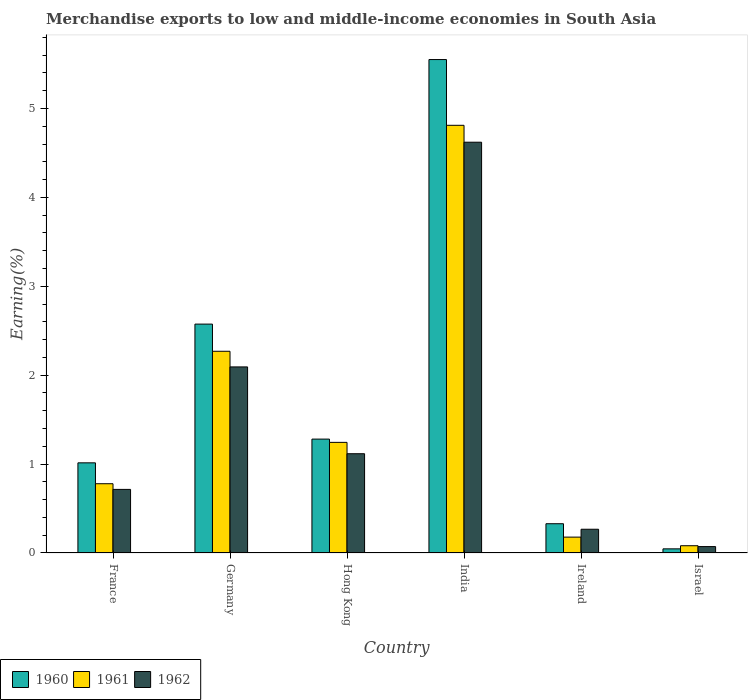How many bars are there on the 2nd tick from the left?
Make the answer very short. 3. How many bars are there on the 1st tick from the right?
Ensure brevity in your answer.  3. What is the label of the 5th group of bars from the left?
Your answer should be very brief. Ireland. What is the percentage of amount earned from merchandise exports in 1960 in Germany?
Your response must be concise. 2.57. Across all countries, what is the maximum percentage of amount earned from merchandise exports in 1960?
Your response must be concise. 5.55. Across all countries, what is the minimum percentage of amount earned from merchandise exports in 1960?
Offer a terse response. 0.05. In which country was the percentage of amount earned from merchandise exports in 1961 minimum?
Provide a succinct answer. Israel. What is the total percentage of amount earned from merchandise exports in 1962 in the graph?
Your answer should be compact. 8.88. What is the difference between the percentage of amount earned from merchandise exports in 1962 in France and that in Hong Kong?
Make the answer very short. -0.4. What is the difference between the percentage of amount earned from merchandise exports in 1962 in Germany and the percentage of amount earned from merchandise exports in 1961 in Israel?
Your response must be concise. 2.01. What is the average percentage of amount earned from merchandise exports in 1962 per country?
Provide a succinct answer. 1.48. What is the difference between the percentage of amount earned from merchandise exports of/in 1961 and percentage of amount earned from merchandise exports of/in 1960 in France?
Give a very brief answer. -0.23. What is the ratio of the percentage of amount earned from merchandise exports in 1961 in Hong Kong to that in India?
Ensure brevity in your answer.  0.26. Is the percentage of amount earned from merchandise exports in 1962 in India less than that in Ireland?
Make the answer very short. No. Is the difference between the percentage of amount earned from merchandise exports in 1961 in Hong Kong and India greater than the difference between the percentage of amount earned from merchandise exports in 1960 in Hong Kong and India?
Make the answer very short. Yes. What is the difference between the highest and the second highest percentage of amount earned from merchandise exports in 1960?
Keep it short and to the point. -1.29. What is the difference between the highest and the lowest percentage of amount earned from merchandise exports in 1960?
Provide a succinct answer. 5.5. In how many countries, is the percentage of amount earned from merchandise exports in 1960 greater than the average percentage of amount earned from merchandise exports in 1960 taken over all countries?
Provide a succinct answer. 2. What does the 1st bar from the left in Ireland represents?
Your answer should be very brief. 1960. What does the 1st bar from the right in Hong Kong represents?
Keep it short and to the point. 1962. What is the difference between two consecutive major ticks on the Y-axis?
Give a very brief answer. 1. Does the graph contain grids?
Your answer should be compact. No. Where does the legend appear in the graph?
Provide a succinct answer. Bottom left. How many legend labels are there?
Make the answer very short. 3. What is the title of the graph?
Offer a terse response. Merchandise exports to low and middle-income economies in South Asia. Does "1960" appear as one of the legend labels in the graph?
Keep it short and to the point. Yes. What is the label or title of the X-axis?
Your response must be concise. Country. What is the label or title of the Y-axis?
Ensure brevity in your answer.  Earning(%). What is the Earning(%) of 1960 in France?
Your response must be concise. 1.01. What is the Earning(%) in 1961 in France?
Your answer should be compact. 0.78. What is the Earning(%) in 1962 in France?
Keep it short and to the point. 0.72. What is the Earning(%) in 1960 in Germany?
Provide a short and direct response. 2.57. What is the Earning(%) of 1961 in Germany?
Make the answer very short. 2.27. What is the Earning(%) in 1962 in Germany?
Provide a succinct answer. 2.09. What is the Earning(%) in 1960 in Hong Kong?
Give a very brief answer. 1.28. What is the Earning(%) of 1961 in Hong Kong?
Offer a terse response. 1.24. What is the Earning(%) in 1962 in Hong Kong?
Offer a terse response. 1.12. What is the Earning(%) of 1960 in India?
Make the answer very short. 5.55. What is the Earning(%) of 1961 in India?
Your answer should be very brief. 4.81. What is the Earning(%) in 1962 in India?
Give a very brief answer. 4.62. What is the Earning(%) of 1960 in Ireland?
Your answer should be compact. 0.33. What is the Earning(%) in 1961 in Ireland?
Provide a short and direct response. 0.18. What is the Earning(%) in 1962 in Ireland?
Your response must be concise. 0.27. What is the Earning(%) in 1960 in Israel?
Provide a succinct answer. 0.05. What is the Earning(%) in 1961 in Israel?
Provide a short and direct response. 0.08. What is the Earning(%) in 1962 in Israel?
Provide a short and direct response. 0.07. Across all countries, what is the maximum Earning(%) of 1960?
Provide a succinct answer. 5.55. Across all countries, what is the maximum Earning(%) in 1961?
Give a very brief answer. 4.81. Across all countries, what is the maximum Earning(%) in 1962?
Provide a succinct answer. 4.62. Across all countries, what is the minimum Earning(%) of 1960?
Your response must be concise. 0.05. Across all countries, what is the minimum Earning(%) of 1961?
Offer a terse response. 0.08. Across all countries, what is the minimum Earning(%) of 1962?
Provide a short and direct response. 0.07. What is the total Earning(%) in 1960 in the graph?
Ensure brevity in your answer.  10.8. What is the total Earning(%) in 1961 in the graph?
Offer a terse response. 9.36. What is the total Earning(%) of 1962 in the graph?
Your answer should be very brief. 8.88. What is the difference between the Earning(%) of 1960 in France and that in Germany?
Keep it short and to the point. -1.56. What is the difference between the Earning(%) of 1961 in France and that in Germany?
Ensure brevity in your answer.  -1.49. What is the difference between the Earning(%) of 1962 in France and that in Germany?
Your answer should be compact. -1.38. What is the difference between the Earning(%) in 1960 in France and that in Hong Kong?
Offer a terse response. -0.27. What is the difference between the Earning(%) of 1961 in France and that in Hong Kong?
Make the answer very short. -0.47. What is the difference between the Earning(%) of 1962 in France and that in Hong Kong?
Provide a succinct answer. -0.4. What is the difference between the Earning(%) in 1960 in France and that in India?
Offer a terse response. -4.54. What is the difference between the Earning(%) in 1961 in France and that in India?
Provide a succinct answer. -4.03. What is the difference between the Earning(%) of 1962 in France and that in India?
Provide a succinct answer. -3.91. What is the difference between the Earning(%) of 1960 in France and that in Ireland?
Offer a terse response. 0.68. What is the difference between the Earning(%) in 1961 in France and that in Ireland?
Ensure brevity in your answer.  0.6. What is the difference between the Earning(%) in 1962 in France and that in Ireland?
Provide a short and direct response. 0.45. What is the difference between the Earning(%) of 1960 in France and that in Israel?
Give a very brief answer. 0.97. What is the difference between the Earning(%) of 1961 in France and that in Israel?
Your answer should be very brief. 0.7. What is the difference between the Earning(%) in 1962 in France and that in Israel?
Ensure brevity in your answer.  0.64. What is the difference between the Earning(%) in 1960 in Germany and that in Hong Kong?
Offer a terse response. 1.29. What is the difference between the Earning(%) of 1961 in Germany and that in Hong Kong?
Offer a terse response. 1.02. What is the difference between the Earning(%) in 1962 in Germany and that in Hong Kong?
Your answer should be compact. 0.98. What is the difference between the Earning(%) of 1960 in Germany and that in India?
Your answer should be compact. -2.98. What is the difference between the Earning(%) in 1961 in Germany and that in India?
Your answer should be compact. -2.54. What is the difference between the Earning(%) in 1962 in Germany and that in India?
Your answer should be compact. -2.53. What is the difference between the Earning(%) in 1960 in Germany and that in Ireland?
Your answer should be very brief. 2.25. What is the difference between the Earning(%) of 1961 in Germany and that in Ireland?
Offer a very short reply. 2.09. What is the difference between the Earning(%) of 1962 in Germany and that in Ireland?
Your answer should be very brief. 1.83. What is the difference between the Earning(%) in 1960 in Germany and that in Israel?
Offer a very short reply. 2.53. What is the difference between the Earning(%) in 1961 in Germany and that in Israel?
Offer a very short reply. 2.19. What is the difference between the Earning(%) of 1962 in Germany and that in Israel?
Offer a very short reply. 2.02. What is the difference between the Earning(%) of 1960 in Hong Kong and that in India?
Your answer should be compact. -4.27. What is the difference between the Earning(%) of 1961 in Hong Kong and that in India?
Make the answer very short. -3.57. What is the difference between the Earning(%) in 1962 in Hong Kong and that in India?
Give a very brief answer. -3.5. What is the difference between the Earning(%) in 1960 in Hong Kong and that in Ireland?
Give a very brief answer. 0.95. What is the difference between the Earning(%) of 1961 in Hong Kong and that in Ireland?
Your response must be concise. 1.07. What is the difference between the Earning(%) in 1962 in Hong Kong and that in Ireland?
Keep it short and to the point. 0.85. What is the difference between the Earning(%) of 1960 in Hong Kong and that in Israel?
Provide a succinct answer. 1.23. What is the difference between the Earning(%) of 1961 in Hong Kong and that in Israel?
Ensure brevity in your answer.  1.16. What is the difference between the Earning(%) of 1962 in Hong Kong and that in Israel?
Provide a short and direct response. 1.04. What is the difference between the Earning(%) of 1960 in India and that in Ireland?
Your answer should be very brief. 5.22. What is the difference between the Earning(%) in 1961 in India and that in Ireland?
Give a very brief answer. 4.63. What is the difference between the Earning(%) in 1962 in India and that in Ireland?
Offer a very short reply. 4.35. What is the difference between the Earning(%) of 1960 in India and that in Israel?
Your answer should be very brief. 5.5. What is the difference between the Earning(%) in 1961 in India and that in Israel?
Make the answer very short. 4.73. What is the difference between the Earning(%) in 1962 in India and that in Israel?
Your answer should be very brief. 4.55. What is the difference between the Earning(%) of 1960 in Ireland and that in Israel?
Offer a very short reply. 0.28. What is the difference between the Earning(%) in 1961 in Ireland and that in Israel?
Your response must be concise. 0.1. What is the difference between the Earning(%) of 1962 in Ireland and that in Israel?
Offer a very short reply. 0.2. What is the difference between the Earning(%) of 1960 in France and the Earning(%) of 1961 in Germany?
Provide a succinct answer. -1.25. What is the difference between the Earning(%) of 1960 in France and the Earning(%) of 1962 in Germany?
Your response must be concise. -1.08. What is the difference between the Earning(%) in 1961 in France and the Earning(%) in 1962 in Germany?
Keep it short and to the point. -1.31. What is the difference between the Earning(%) of 1960 in France and the Earning(%) of 1961 in Hong Kong?
Ensure brevity in your answer.  -0.23. What is the difference between the Earning(%) of 1960 in France and the Earning(%) of 1962 in Hong Kong?
Offer a very short reply. -0.1. What is the difference between the Earning(%) of 1961 in France and the Earning(%) of 1962 in Hong Kong?
Provide a succinct answer. -0.34. What is the difference between the Earning(%) in 1960 in France and the Earning(%) in 1961 in India?
Your answer should be compact. -3.8. What is the difference between the Earning(%) in 1960 in France and the Earning(%) in 1962 in India?
Your answer should be very brief. -3.61. What is the difference between the Earning(%) of 1961 in France and the Earning(%) of 1962 in India?
Your answer should be compact. -3.84. What is the difference between the Earning(%) in 1960 in France and the Earning(%) in 1961 in Ireland?
Provide a short and direct response. 0.84. What is the difference between the Earning(%) of 1960 in France and the Earning(%) of 1962 in Ireland?
Keep it short and to the point. 0.75. What is the difference between the Earning(%) in 1961 in France and the Earning(%) in 1962 in Ireland?
Make the answer very short. 0.51. What is the difference between the Earning(%) in 1960 in France and the Earning(%) in 1961 in Israel?
Your answer should be very brief. 0.93. What is the difference between the Earning(%) in 1960 in France and the Earning(%) in 1962 in Israel?
Offer a very short reply. 0.94. What is the difference between the Earning(%) of 1961 in France and the Earning(%) of 1962 in Israel?
Give a very brief answer. 0.71. What is the difference between the Earning(%) in 1960 in Germany and the Earning(%) in 1961 in Hong Kong?
Ensure brevity in your answer.  1.33. What is the difference between the Earning(%) of 1960 in Germany and the Earning(%) of 1962 in Hong Kong?
Your response must be concise. 1.46. What is the difference between the Earning(%) of 1961 in Germany and the Earning(%) of 1962 in Hong Kong?
Provide a succinct answer. 1.15. What is the difference between the Earning(%) of 1960 in Germany and the Earning(%) of 1961 in India?
Make the answer very short. -2.24. What is the difference between the Earning(%) of 1960 in Germany and the Earning(%) of 1962 in India?
Provide a succinct answer. -2.05. What is the difference between the Earning(%) in 1961 in Germany and the Earning(%) in 1962 in India?
Ensure brevity in your answer.  -2.35. What is the difference between the Earning(%) in 1960 in Germany and the Earning(%) in 1961 in Ireland?
Provide a short and direct response. 2.4. What is the difference between the Earning(%) of 1960 in Germany and the Earning(%) of 1962 in Ireland?
Your response must be concise. 2.31. What is the difference between the Earning(%) of 1961 in Germany and the Earning(%) of 1962 in Ireland?
Offer a terse response. 2. What is the difference between the Earning(%) of 1960 in Germany and the Earning(%) of 1961 in Israel?
Your answer should be very brief. 2.49. What is the difference between the Earning(%) in 1960 in Germany and the Earning(%) in 1962 in Israel?
Offer a terse response. 2.5. What is the difference between the Earning(%) in 1961 in Germany and the Earning(%) in 1962 in Israel?
Provide a succinct answer. 2.2. What is the difference between the Earning(%) in 1960 in Hong Kong and the Earning(%) in 1961 in India?
Keep it short and to the point. -3.53. What is the difference between the Earning(%) in 1960 in Hong Kong and the Earning(%) in 1962 in India?
Give a very brief answer. -3.34. What is the difference between the Earning(%) of 1961 in Hong Kong and the Earning(%) of 1962 in India?
Give a very brief answer. -3.38. What is the difference between the Earning(%) of 1960 in Hong Kong and the Earning(%) of 1961 in Ireland?
Provide a succinct answer. 1.1. What is the difference between the Earning(%) in 1960 in Hong Kong and the Earning(%) in 1962 in Ireland?
Provide a succinct answer. 1.01. What is the difference between the Earning(%) in 1961 in Hong Kong and the Earning(%) in 1962 in Ireland?
Keep it short and to the point. 0.98. What is the difference between the Earning(%) of 1960 in Hong Kong and the Earning(%) of 1961 in Israel?
Keep it short and to the point. 1.2. What is the difference between the Earning(%) in 1960 in Hong Kong and the Earning(%) in 1962 in Israel?
Provide a short and direct response. 1.21. What is the difference between the Earning(%) in 1961 in Hong Kong and the Earning(%) in 1962 in Israel?
Provide a short and direct response. 1.17. What is the difference between the Earning(%) in 1960 in India and the Earning(%) in 1961 in Ireland?
Your answer should be compact. 5.37. What is the difference between the Earning(%) of 1960 in India and the Earning(%) of 1962 in Ireland?
Your response must be concise. 5.28. What is the difference between the Earning(%) of 1961 in India and the Earning(%) of 1962 in Ireland?
Keep it short and to the point. 4.54. What is the difference between the Earning(%) of 1960 in India and the Earning(%) of 1961 in Israel?
Make the answer very short. 5.47. What is the difference between the Earning(%) of 1960 in India and the Earning(%) of 1962 in Israel?
Provide a succinct answer. 5.48. What is the difference between the Earning(%) in 1961 in India and the Earning(%) in 1962 in Israel?
Keep it short and to the point. 4.74. What is the difference between the Earning(%) in 1960 in Ireland and the Earning(%) in 1961 in Israel?
Offer a terse response. 0.25. What is the difference between the Earning(%) of 1960 in Ireland and the Earning(%) of 1962 in Israel?
Ensure brevity in your answer.  0.26. What is the difference between the Earning(%) in 1961 in Ireland and the Earning(%) in 1962 in Israel?
Your response must be concise. 0.11. What is the average Earning(%) of 1960 per country?
Provide a succinct answer. 1.8. What is the average Earning(%) in 1961 per country?
Offer a terse response. 1.56. What is the average Earning(%) of 1962 per country?
Offer a terse response. 1.48. What is the difference between the Earning(%) of 1960 and Earning(%) of 1961 in France?
Provide a short and direct response. 0.23. What is the difference between the Earning(%) in 1960 and Earning(%) in 1962 in France?
Provide a succinct answer. 0.3. What is the difference between the Earning(%) in 1961 and Earning(%) in 1962 in France?
Provide a succinct answer. 0.06. What is the difference between the Earning(%) in 1960 and Earning(%) in 1961 in Germany?
Ensure brevity in your answer.  0.31. What is the difference between the Earning(%) in 1960 and Earning(%) in 1962 in Germany?
Keep it short and to the point. 0.48. What is the difference between the Earning(%) of 1961 and Earning(%) of 1962 in Germany?
Keep it short and to the point. 0.18. What is the difference between the Earning(%) in 1960 and Earning(%) in 1961 in Hong Kong?
Offer a very short reply. 0.04. What is the difference between the Earning(%) in 1960 and Earning(%) in 1962 in Hong Kong?
Provide a succinct answer. 0.16. What is the difference between the Earning(%) in 1961 and Earning(%) in 1962 in Hong Kong?
Your response must be concise. 0.13. What is the difference between the Earning(%) in 1960 and Earning(%) in 1961 in India?
Offer a very short reply. 0.74. What is the difference between the Earning(%) in 1960 and Earning(%) in 1962 in India?
Provide a succinct answer. 0.93. What is the difference between the Earning(%) in 1961 and Earning(%) in 1962 in India?
Keep it short and to the point. 0.19. What is the difference between the Earning(%) of 1960 and Earning(%) of 1961 in Ireland?
Make the answer very short. 0.15. What is the difference between the Earning(%) of 1960 and Earning(%) of 1962 in Ireland?
Offer a terse response. 0.06. What is the difference between the Earning(%) in 1961 and Earning(%) in 1962 in Ireland?
Provide a succinct answer. -0.09. What is the difference between the Earning(%) in 1960 and Earning(%) in 1961 in Israel?
Offer a terse response. -0.04. What is the difference between the Earning(%) in 1960 and Earning(%) in 1962 in Israel?
Your response must be concise. -0.03. What is the difference between the Earning(%) in 1961 and Earning(%) in 1962 in Israel?
Provide a succinct answer. 0.01. What is the ratio of the Earning(%) in 1960 in France to that in Germany?
Your answer should be very brief. 0.39. What is the ratio of the Earning(%) in 1961 in France to that in Germany?
Offer a very short reply. 0.34. What is the ratio of the Earning(%) of 1962 in France to that in Germany?
Provide a succinct answer. 0.34. What is the ratio of the Earning(%) in 1960 in France to that in Hong Kong?
Give a very brief answer. 0.79. What is the ratio of the Earning(%) of 1961 in France to that in Hong Kong?
Offer a very short reply. 0.63. What is the ratio of the Earning(%) in 1962 in France to that in Hong Kong?
Give a very brief answer. 0.64. What is the ratio of the Earning(%) in 1960 in France to that in India?
Ensure brevity in your answer.  0.18. What is the ratio of the Earning(%) of 1961 in France to that in India?
Offer a very short reply. 0.16. What is the ratio of the Earning(%) in 1962 in France to that in India?
Make the answer very short. 0.15. What is the ratio of the Earning(%) in 1960 in France to that in Ireland?
Your answer should be very brief. 3.08. What is the ratio of the Earning(%) of 1961 in France to that in Ireland?
Your answer should be compact. 4.36. What is the ratio of the Earning(%) of 1962 in France to that in Ireland?
Ensure brevity in your answer.  2.68. What is the ratio of the Earning(%) in 1960 in France to that in Israel?
Your answer should be very brief. 21.76. What is the ratio of the Earning(%) of 1961 in France to that in Israel?
Keep it short and to the point. 9.53. What is the ratio of the Earning(%) of 1962 in France to that in Israel?
Ensure brevity in your answer.  9.94. What is the ratio of the Earning(%) in 1960 in Germany to that in Hong Kong?
Provide a short and direct response. 2.01. What is the ratio of the Earning(%) of 1961 in Germany to that in Hong Kong?
Offer a very short reply. 1.82. What is the ratio of the Earning(%) in 1962 in Germany to that in Hong Kong?
Your answer should be very brief. 1.87. What is the ratio of the Earning(%) of 1960 in Germany to that in India?
Offer a terse response. 0.46. What is the ratio of the Earning(%) of 1961 in Germany to that in India?
Your answer should be very brief. 0.47. What is the ratio of the Earning(%) of 1962 in Germany to that in India?
Your answer should be very brief. 0.45. What is the ratio of the Earning(%) in 1960 in Germany to that in Ireland?
Offer a very short reply. 7.82. What is the ratio of the Earning(%) in 1961 in Germany to that in Ireland?
Provide a short and direct response. 12.71. What is the ratio of the Earning(%) of 1962 in Germany to that in Ireland?
Your answer should be very brief. 7.83. What is the ratio of the Earning(%) of 1960 in Germany to that in Israel?
Keep it short and to the point. 55.25. What is the ratio of the Earning(%) in 1961 in Germany to that in Israel?
Your answer should be very brief. 27.76. What is the ratio of the Earning(%) in 1962 in Germany to that in Israel?
Your answer should be compact. 29.07. What is the ratio of the Earning(%) of 1960 in Hong Kong to that in India?
Provide a short and direct response. 0.23. What is the ratio of the Earning(%) in 1961 in Hong Kong to that in India?
Make the answer very short. 0.26. What is the ratio of the Earning(%) in 1962 in Hong Kong to that in India?
Offer a terse response. 0.24. What is the ratio of the Earning(%) of 1960 in Hong Kong to that in Ireland?
Offer a very short reply. 3.89. What is the ratio of the Earning(%) in 1961 in Hong Kong to that in Ireland?
Make the answer very short. 6.97. What is the ratio of the Earning(%) of 1962 in Hong Kong to that in Ireland?
Provide a succinct answer. 4.18. What is the ratio of the Earning(%) in 1960 in Hong Kong to that in Israel?
Make the answer very short. 27.49. What is the ratio of the Earning(%) of 1961 in Hong Kong to that in Israel?
Offer a very short reply. 15.22. What is the ratio of the Earning(%) in 1962 in Hong Kong to that in Israel?
Keep it short and to the point. 15.51. What is the ratio of the Earning(%) in 1960 in India to that in Ireland?
Provide a short and direct response. 16.86. What is the ratio of the Earning(%) in 1961 in India to that in Ireland?
Keep it short and to the point. 26.95. What is the ratio of the Earning(%) in 1962 in India to that in Ireland?
Keep it short and to the point. 17.29. What is the ratio of the Earning(%) of 1960 in India to that in Israel?
Offer a very short reply. 119.1. What is the ratio of the Earning(%) in 1961 in India to that in Israel?
Give a very brief answer. 58.86. What is the ratio of the Earning(%) in 1962 in India to that in Israel?
Keep it short and to the point. 64.18. What is the ratio of the Earning(%) in 1960 in Ireland to that in Israel?
Provide a short and direct response. 7.06. What is the ratio of the Earning(%) in 1961 in Ireland to that in Israel?
Give a very brief answer. 2.18. What is the ratio of the Earning(%) of 1962 in Ireland to that in Israel?
Make the answer very short. 3.71. What is the difference between the highest and the second highest Earning(%) of 1960?
Provide a short and direct response. 2.98. What is the difference between the highest and the second highest Earning(%) in 1961?
Ensure brevity in your answer.  2.54. What is the difference between the highest and the second highest Earning(%) in 1962?
Offer a very short reply. 2.53. What is the difference between the highest and the lowest Earning(%) of 1960?
Provide a short and direct response. 5.5. What is the difference between the highest and the lowest Earning(%) in 1961?
Ensure brevity in your answer.  4.73. What is the difference between the highest and the lowest Earning(%) of 1962?
Offer a terse response. 4.55. 